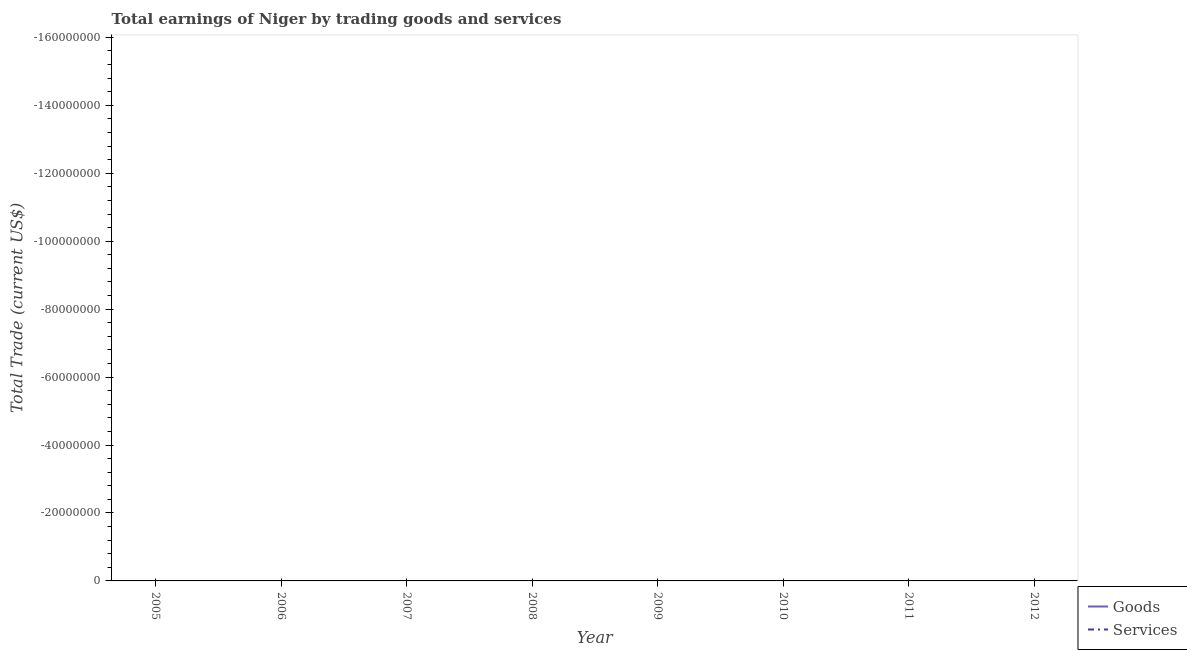Does the line corresponding to amount earned by trading services intersect with the line corresponding to amount earned by trading goods?
Your answer should be very brief. No. What is the amount earned by trading goods in 2012?
Offer a very short reply. 0. What is the total amount earned by trading services in the graph?
Offer a very short reply. 0. Does the amount earned by trading goods monotonically increase over the years?
Your answer should be compact. No. Is the amount earned by trading services strictly greater than the amount earned by trading goods over the years?
Ensure brevity in your answer.  No. Is the amount earned by trading services strictly less than the amount earned by trading goods over the years?
Keep it short and to the point. Yes. How many lines are there?
Provide a short and direct response. 0. What is the difference between two consecutive major ticks on the Y-axis?
Provide a succinct answer. 2.00e+07. Are the values on the major ticks of Y-axis written in scientific E-notation?
Your answer should be compact. No. Does the graph contain any zero values?
Make the answer very short. Yes. Does the graph contain grids?
Give a very brief answer. No. Where does the legend appear in the graph?
Your response must be concise. Bottom right. How are the legend labels stacked?
Provide a succinct answer. Vertical. What is the title of the graph?
Provide a succinct answer. Total earnings of Niger by trading goods and services. What is the label or title of the Y-axis?
Ensure brevity in your answer.  Total Trade (current US$). What is the Total Trade (current US$) in Goods in 2006?
Offer a very short reply. 0. What is the Total Trade (current US$) of Services in 2006?
Provide a short and direct response. 0. What is the Total Trade (current US$) of Services in 2007?
Provide a short and direct response. 0. What is the Total Trade (current US$) in Goods in 2008?
Your answer should be very brief. 0. What is the Total Trade (current US$) of Services in 2008?
Your answer should be very brief. 0. What is the Total Trade (current US$) in Goods in 2009?
Provide a short and direct response. 0. What is the Total Trade (current US$) of Goods in 2010?
Keep it short and to the point. 0. What is the Total Trade (current US$) in Services in 2010?
Keep it short and to the point. 0. What is the Total Trade (current US$) in Services in 2011?
Offer a very short reply. 0. What is the average Total Trade (current US$) of Goods per year?
Your answer should be very brief. 0. What is the average Total Trade (current US$) of Services per year?
Your response must be concise. 0. 